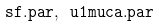Convert formula to latex. <formula><loc_0><loc_0><loc_500><loc_500>\tt s f . p a r , \ u 1 m u c a . p a r</formula> 